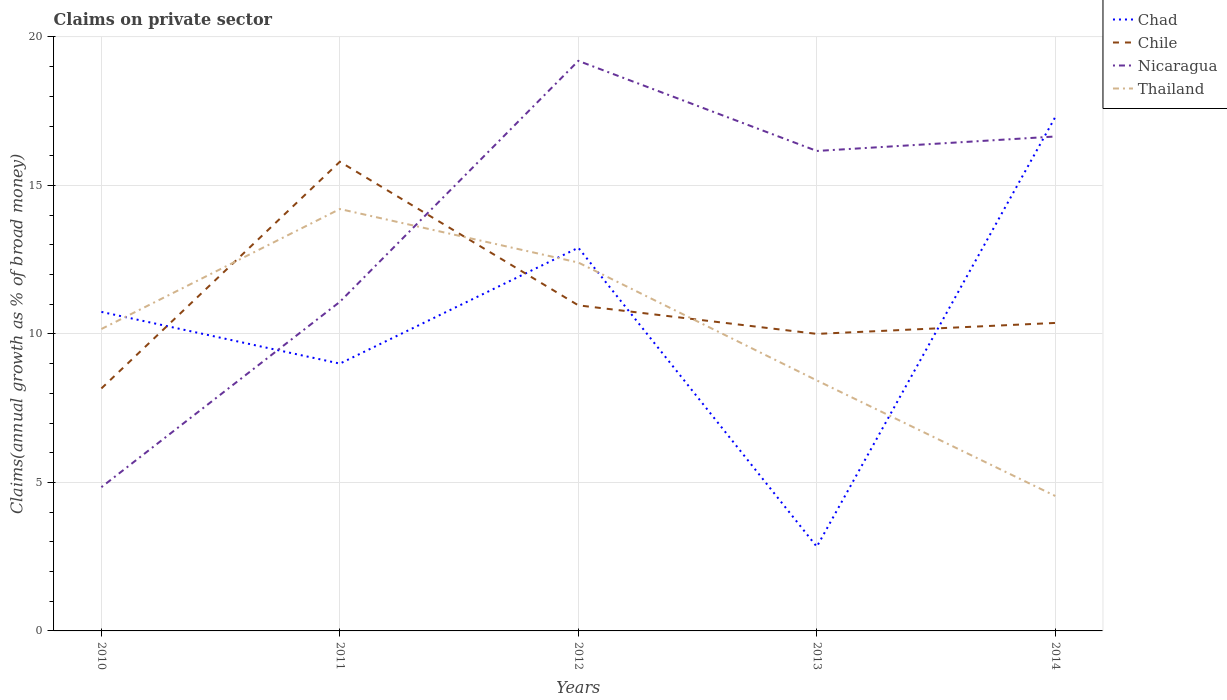How many different coloured lines are there?
Offer a terse response. 4. Across all years, what is the maximum percentage of broad money claimed on private sector in Thailand?
Provide a short and direct response. 4.54. In which year was the percentage of broad money claimed on private sector in Chad maximum?
Provide a short and direct response. 2013. What is the total percentage of broad money claimed on private sector in Nicaragua in the graph?
Your response must be concise. 2.55. What is the difference between the highest and the second highest percentage of broad money claimed on private sector in Chile?
Offer a terse response. 7.63. What is the difference between the highest and the lowest percentage of broad money claimed on private sector in Chad?
Give a very brief answer. 3. Is the percentage of broad money claimed on private sector in Chad strictly greater than the percentage of broad money claimed on private sector in Chile over the years?
Your response must be concise. No. How many lines are there?
Offer a very short reply. 4. Does the graph contain any zero values?
Ensure brevity in your answer.  No. Where does the legend appear in the graph?
Ensure brevity in your answer.  Top right. How many legend labels are there?
Provide a succinct answer. 4. How are the legend labels stacked?
Keep it short and to the point. Vertical. What is the title of the graph?
Give a very brief answer. Claims on private sector. Does "Guatemala" appear as one of the legend labels in the graph?
Keep it short and to the point. No. What is the label or title of the Y-axis?
Ensure brevity in your answer.  Claims(annual growth as % of broad money). What is the Claims(annual growth as % of broad money) of Chad in 2010?
Offer a terse response. 10.74. What is the Claims(annual growth as % of broad money) in Chile in 2010?
Your answer should be compact. 8.16. What is the Claims(annual growth as % of broad money) of Nicaragua in 2010?
Your response must be concise. 4.84. What is the Claims(annual growth as % of broad money) of Thailand in 2010?
Make the answer very short. 10.17. What is the Claims(annual growth as % of broad money) of Chad in 2011?
Your answer should be very brief. 9. What is the Claims(annual growth as % of broad money) of Chile in 2011?
Keep it short and to the point. 15.8. What is the Claims(annual growth as % of broad money) of Nicaragua in 2011?
Make the answer very short. 11.08. What is the Claims(annual growth as % of broad money) of Thailand in 2011?
Make the answer very short. 14.21. What is the Claims(annual growth as % of broad money) of Chad in 2012?
Provide a succinct answer. 12.9. What is the Claims(annual growth as % of broad money) in Chile in 2012?
Provide a succinct answer. 10.96. What is the Claims(annual growth as % of broad money) in Nicaragua in 2012?
Your answer should be very brief. 19.2. What is the Claims(annual growth as % of broad money) of Thailand in 2012?
Make the answer very short. 12.4. What is the Claims(annual growth as % of broad money) in Chad in 2013?
Give a very brief answer. 2.84. What is the Claims(annual growth as % of broad money) in Chile in 2013?
Ensure brevity in your answer.  10. What is the Claims(annual growth as % of broad money) of Nicaragua in 2013?
Your answer should be very brief. 16.16. What is the Claims(annual growth as % of broad money) in Thailand in 2013?
Offer a very short reply. 8.44. What is the Claims(annual growth as % of broad money) of Chad in 2014?
Provide a short and direct response. 17.3. What is the Claims(annual growth as % of broad money) in Chile in 2014?
Provide a succinct answer. 10.37. What is the Claims(annual growth as % of broad money) of Nicaragua in 2014?
Ensure brevity in your answer.  16.65. What is the Claims(annual growth as % of broad money) in Thailand in 2014?
Provide a short and direct response. 4.54. Across all years, what is the maximum Claims(annual growth as % of broad money) in Chad?
Your answer should be very brief. 17.3. Across all years, what is the maximum Claims(annual growth as % of broad money) in Chile?
Keep it short and to the point. 15.8. Across all years, what is the maximum Claims(annual growth as % of broad money) of Nicaragua?
Ensure brevity in your answer.  19.2. Across all years, what is the maximum Claims(annual growth as % of broad money) in Thailand?
Your answer should be compact. 14.21. Across all years, what is the minimum Claims(annual growth as % of broad money) of Chad?
Give a very brief answer. 2.84. Across all years, what is the minimum Claims(annual growth as % of broad money) in Chile?
Offer a terse response. 8.16. Across all years, what is the minimum Claims(annual growth as % of broad money) of Nicaragua?
Offer a very short reply. 4.84. Across all years, what is the minimum Claims(annual growth as % of broad money) in Thailand?
Give a very brief answer. 4.54. What is the total Claims(annual growth as % of broad money) in Chad in the graph?
Give a very brief answer. 52.79. What is the total Claims(annual growth as % of broad money) of Chile in the graph?
Your answer should be very brief. 55.3. What is the total Claims(annual growth as % of broad money) in Nicaragua in the graph?
Offer a terse response. 67.93. What is the total Claims(annual growth as % of broad money) in Thailand in the graph?
Offer a terse response. 49.76. What is the difference between the Claims(annual growth as % of broad money) of Chad in 2010 and that in 2011?
Your response must be concise. 1.74. What is the difference between the Claims(annual growth as % of broad money) in Chile in 2010 and that in 2011?
Provide a short and direct response. -7.63. What is the difference between the Claims(annual growth as % of broad money) in Nicaragua in 2010 and that in 2011?
Make the answer very short. -6.24. What is the difference between the Claims(annual growth as % of broad money) of Thailand in 2010 and that in 2011?
Keep it short and to the point. -4.04. What is the difference between the Claims(annual growth as % of broad money) in Chad in 2010 and that in 2012?
Provide a succinct answer. -2.16. What is the difference between the Claims(annual growth as % of broad money) in Chile in 2010 and that in 2012?
Give a very brief answer. -2.8. What is the difference between the Claims(annual growth as % of broad money) of Nicaragua in 2010 and that in 2012?
Make the answer very short. -14.35. What is the difference between the Claims(annual growth as % of broad money) of Thailand in 2010 and that in 2012?
Provide a short and direct response. -2.24. What is the difference between the Claims(annual growth as % of broad money) in Chad in 2010 and that in 2013?
Your response must be concise. 7.91. What is the difference between the Claims(annual growth as % of broad money) of Chile in 2010 and that in 2013?
Provide a short and direct response. -1.84. What is the difference between the Claims(annual growth as % of broad money) in Nicaragua in 2010 and that in 2013?
Provide a succinct answer. -11.32. What is the difference between the Claims(annual growth as % of broad money) of Thailand in 2010 and that in 2013?
Your response must be concise. 1.73. What is the difference between the Claims(annual growth as % of broad money) in Chad in 2010 and that in 2014?
Offer a very short reply. -6.56. What is the difference between the Claims(annual growth as % of broad money) in Chile in 2010 and that in 2014?
Give a very brief answer. -2.21. What is the difference between the Claims(annual growth as % of broad money) in Nicaragua in 2010 and that in 2014?
Offer a terse response. -11.81. What is the difference between the Claims(annual growth as % of broad money) of Thailand in 2010 and that in 2014?
Give a very brief answer. 5.62. What is the difference between the Claims(annual growth as % of broad money) in Chad in 2011 and that in 2012?
Make the answer very short. -3.9. What is the difference between the Claims(annual growth as % of broad money) in Chile in 2011 and that in 2012?
Provide a short and direct response. 4.84. What is the difference between the Claims(annual growth as % of broad money) of Nicaragua in 2011 and that in 2012?
Provide a succinct answer. -8.11. What is the difference between the Claims(annual growth as % of broad money) in Thailand in 2011 and that in 2012?
Offer a very short reply. 1.8. What is the difference between the Claims(annual growth as % of broad money) of Chad in 2011 and that in 2013?
Provide a short and direct response. 6.17. What is the difference between the Claims(annual growth as % of broad money) in Chile in 2011 and that in 2013?
Keep it short and to the point. 5.8. What is the difference between the Claims(annual growth as % of broad money) of Nicaragua in 2011 and that in 2013?
Your answer should be very brief. -5.08. What is the difference between the Claims(annual growth as % of broad money) in Thailand in 2011 and that in 2013?
Keep it short and to the point. 5.77. What is the difference between the Claims(annual growth as % of broad money) in Chad in 2011 and that in 2014?
Offer a very short reply. -8.3. What is the difference between the Claims(annual growth as % of broad money) of Chile in 2011 and that in 2014?
Your answer should be compact. 5.43. What is the difference between the Claims(annual growth as % of broad money) of Nicaragua in 2011 and that in 2014?
Offer a terse response. -5.57. What is the difference between the Claims(annual growth as % of broad money) of Thailand in 2011 and that in 2014?
Your answer should be very brief. 9.66. What is the difference between the Claims(annual growth as % of broad money) of Chad in 2012 and that in 2013?
Provide a succinct answer. 10.07. What is the difference between the Claims(annual growth as % of broad money) in Chile in 2012 and that in 2013?
Ensure brevity in your answer.  0.96. What is the difference between the Claims(annual growth as % of broad money) of Nicaragua in 2012 and that in 2013?
Offer a terse response. 3.03. What is the difference between the Claims(annual growth as % of broad money) in Thailand in 2012 and that in 2013?
Provide a succinct answer. 3.97. What is the difference between the Claims(annual growth as % of broad money) of Chad in 2012 and that in 2014?
Offer a very short reply. -4.4. What is the difference between the Claims(annual growth as % of broad money) in Chile in 2012 and that in 2014?
Your response must be concise. 0.59. What is the difference between the Claims(annual growth as % of broad money) in Nicaragua in 2012 and that in 2014?
Provide a short and direct response. 2.55. What is the difference between the Claims(annual growth as % of broad money) in Thailand in 2012 and that in 2014?
Your response must be concise. 7.86. What is the difference between the Claims(annual growth as % of broad money) of Chad in 2013 and that in 2014?
Provide a short and direct response. -14.47. What is the difference between the Claims(annual growth as % of broad money) in Chile in 2013 and that in 2014?
Give a very brief answer. -0.37. What is the difference between the Claims(annual growth as % of broad money) in Nicaragua in 2013 and that in 2014?
Your answer should be very brief. -0.49. What is the difference between the Claims(annual growth as % of broad money) in Thailand in 2013 and that in 2014?
Your answer should be compact. 3.89. What is the difference between the Claims(annual growth as % of broad money) in Chad in 2010 and the Claims(annual growth as % of broad money) in Chile in 2011?
Make the answer very short. -5.06. What is the difference between the Claims(annual growth as % of broad money) of Chad in 2010 and the Claims(annual growth as % of broad money) of Nicaragua in 2011?
Provide a short and direct response. -0.34. What is the difference between the Claims(annual growth as % of broad money) of Chad in 2010 and the Claims(annual growth as % of broad money) of Thailand in 2011?
Make the answer very short. -3.46. What is the difference between the Claims(annual growth as % of broad money) of Chile in 2010 and the Claims(annual growth as % of broad money) of Nicaragua in 2011?
Your response must be concise. -2.92. What is the difference between the Claims(annual growth as % of broad money) in Chile in 2010 and the Claims(annual growth as % of broad money) in Thailand in 2011?
Keep it short and to the point. -6.04. What is the difference between the Claims(annual growth as % of broad money) in Nicaragua in 2010 and the Claims(annual growth as % of broad money) in Thailand in 2011?
Keep it short and to the point. -9.37. What is the difference between the Claims(annual growth as % of broad money) in Chad in 2010 and the Claims(annual growth as % of broad money) in Chile in 2012?
Your response must be concise. -0.22. What is the difference between the Claims(annual growth as % of broad money) in Chad in 2010 and the Claims(annual growth as % of broad money) in Nicaragua in 2012?
Offer a very short reply. -8.45. What is the difference between the Claims(annual growth as % of broad money) in Chad in 2010 and the Claims(annual growth as % of broad money) in Thailand in 2012?
Provide a short and direct response. -1.66. What is the difference between the Claims(annual growth as % of broad money) of Chile in 2010 and the Claims(annual growth as % of broad money) of Nicaragua in 2012?
Offer a terse response. -11.03. What is the difference between the Claims(annual growth as % of broad money) of Chile in 2010 and the Claims(annual growth as % of broad money) of Thailand in 2012?
Your response must be concise. -4.24. What is the difference between the Claims(annual growth as % of broad money) of Nicaragua in 2010 and the Claims(annual growth as % of broad money) of Thailand in 2012?
Ensure brevity in your answer.  -7.56. What is the difference between the Claims(annual growth as % of broad money) of Chad in 2010 and the Claims(annual growth as % of broad money) of Chile in 2013?
Give a very brief answer. 0.74. What is the difference between the Claims(annual growth as % of broad money) in Chad in 2010 and the Claims(annual growth as % of broad money) in Nicaragua in 2013?
Offer a terse response. -5.42. What is the difference between the Claims(annual growth as % of broad money) of Chad in 2010 and the Claims(annual growth as % of broad money) of Thailand in 2013?
Your answer should be compact. 2.31. What is the difference between the Claims(annual growth as % of broad money) of Chile in 2010 and the Claims(annual growth as % of broad money) of Nicaragua in 2013?
Your answer should be compact. -8. What is the difference between the Claims(annual growth as % of broad money) in Chile in 2010 and the Claims(annual growth as % of broad money) in Thailand in 2013?
Offer a very short reply. -0.27. What is the difference between the Claims(annual growth as % of broad money) in Nicaragua in 2010 and the Claims(annual growth as % of broad money) in Thailand in 2013?
Offer a terse response. -3.59. What is the difference between the Claims(annual growth as % of broad money) of Chad in 2010 and the Claims(annual growth as % of broad money) of Chile in 2014?
Your answer should be very brief. 0.37. What is the difference between the Claims(annual growth as % of broad money) in Chad in 2010 and the Claims(annual growth as % of broad money) in Nicaragua in 2014?
Offer a very short reply. -5.91. What is the difference between the Claims(annual growth as % of broad money) of Chad in 2010 and the Claims(annual growth as % of broad money) of Thailand in 2014?
Your answer should be compact. 6.2. What is the difference between the Claims(annual growth as % of broad money) of Chile in 2010 and the Claims(annual growth as % of broad money) of Nicaragua in 2014?
Your answer should be compact. -8.48. What is the difference between the Claims(annual growth as % of broad money) of Chile in 2010 and the Claims(annual growth as % of broad money) of Thailand in 2014?
Offer a terse response. 3.62. What is the difference between the Claims(annual growth as % of broad money) of Nicaragua in 2010 and the Claims(annual growth as % of broad money) of Thailand in 2014?
Your response must be concise. 0.3. What is the difference between the Claims(annual growth as % of broad money) in Chad in 2011 and the Claims(annual growth as % of broad money) in Chile in 2012?
Give a very brief answer. -1.96. What is the difference between the Claims(annual growth as % of broad money) of Chad in 2011 and the Claims(annual growth as % of broad money) of Nicaragua in 2012?
Ensure brevity in your answer.  -10.19. What is the difference between the Claims(annual growth as % of broad money) in Chad in 2011 and the Claims(annual growth as % of broad money) in Thailand in 2012?
Make the answer very short. -3.4. What is the difference between the Claims(annual growth as % of broad money) of Chile in 2011 and the Claims(annual growth as % of broad money) of Nicaragua in 2012?
Give a very brief answer. -3.4. What is the difference between the Claims(annual growth as % of broad money) of Chile in 2011 and the Claims(annual growth as % of broad money) of Thailand in 2012?
Give a very brief answer. 3.4. What is the difference between the Claims(annual growth as % of broad money) of Nicaragua in 2011 and the Claims(annual growth as % of broad money) of Thailand in 2012?
Your answer should be very brief. -1.32. What is the difference between the Claims(annual growth as % of broad money) in Chad in 2011 and the Claims(annual growth as % of broad money) in Chile in 2013?
Offer a terse response. -1. What is the difference between the Claims(annual growth as % of broad money) in Chad in 2011 and the Claims(annual growth as % of broad money) in Nicaragua in 2013?
Offer a very short reply. -7.16. What is the difference between the Claims(annual growth as % of broad money) in Chad in 2011 and the Claims(annual growth as % of broad money) in Thailand in 2013?
Offer a terse response. 0.57. What is the difference between the Claims(annual growth as % of broad money) of Chile in 2011 and the Claims(annual growth as % of broad money) of Nicaragua in 2013?
Your answer should be compact. -0.36. What is the difference between the Claims(annual growth as % of broad money) in Chile in 2011 and the Claims(annual growth as % of broad money) in Thailand in 2013?
Ensure brevity in your answer.  7.36. What is the difference between the Claims(annual growth as % of broad money) in Nicaragua in 2011 and the Claims(annual growth as % of broad money) in Thailand in 2013?
Offer a very short reply. 2.65. What is the difference between the Claims(annual growth as % of broad money) of Chad in 2011 and the Claims(annual growth as % of broad money) of Chile in 2014?
Keep it short and to the point. -1.37. What is the difference between the Claims(annual growth as % of broad money) of Chad in 2011 and the Claims(annual growth as % of broad money) of Nicaragua in 2014?
Offer a very short reply. -7.65. What is the difference between the Claims(annual growth as % of broad money) of Chad in 2011 and the Claims(annual growth as % of broad money) of Thailand in 2014?
Ensure brevity in your answer.  4.46. What is the difference between the Claims(annual growth as % of broad money) of Chile in 2011 and the Claims(annual growth as % of broad money) of Nicaragua in 2014?
Your answer should be very brief. -0.85. What is the difference between the Claims(annual growth as % of broad money) in Chile in 2011 and the Claims(annual growth as % of broad money) in Thailand in 2014?
Your answer should be compact. 11.26. What is the difference between the Claims(annual growth as % of broad money) in Nicaragua in 2011 and the Claims(annual growth as % of broad money) in Thailand in 2014?
Provide a short and direct response. 6.54. What is the difference between the Claims(annual growth as % of broad money) of Chad in 2012 and the Claims(annual growth as % of broad money) of Chile in 2013?
Give a very brief answer. 2.9. What is the difference between the Claims(annual growth as % of broad money) of Chad in 2012 and the Claims(annual growth as % of broad money) of Nicaragua in 2013?
Offer a very short reply. -3.26. What is the difference between the Claims(annual growth as % of broad money) of Chad in 2012 and the Claims(annual growth as % of broad money) of Thailand in 2013?
Provide a short and direct response. 4.47. What is the difference between the Claims(annual growth as % of broad money) in Chile in 2012 and the Claims(annual growth as % of broad money) in Nicaragua in 2013?
Provide a succinct answer. -5.2. What is the difference between the Claims(annual growth as % of broad money) in Chile in 2012 and the Claims(annual growth as % of broad money) in Thailand in 2013?
Offer a terse response. 2.53. What is the difference between the Claims(annual growth as % of broad money) of Nicaragua in 2012 and the Claims(annual growth as % of broad money) of Thailand in 2013?
Your answer should be very brief. 10.76. What is the difference between the Claims(annual growth as % of broad money) of Chad in 2012 and the Claims(annual growth as % of broad money) of Chile in 2014?
Ensure brevity in your answer.  2.53. What is the difference between the Claims(annual growth as % of broad money) of Chad in 2012 and the Claims(annual growth as % of broad money) of Nicaragua in 2014?
Make the answer very short. -3.75. What is the difference between the Claims(annual growth as % of broad money) of Chad in 2012 and the Claims(annual growth as % of broad money) of Thailand in 2014?
Keep it short and to the point. 8.36. What is the difference between the Claims(annual growth as % of broad money) of Chile in 2012 and the Claims(annual growth as % of broad money) of Nicaragua in 2014?
Make the answer very short. -5.69. What is the difference between the Claims(annual growth as % of broad money) in Chile in 2012 and the Claims(annual growth as % of broad money) in Thailand in 2014?
Ensure brevity in your answer.  6.42. What is the difference between the Claims(annual growth as % of broad money) in Nicaragua in 2012 and the Claims(annual growth as % of broad money) in Thailand in 2014?
Offer a very short reply. 14.65. What is the difference between the Claims(annual growth as % of broad money) of Chad in 2013 and the Claims(annual growth as % of broad money) of Chile in 2014?
Your response must be concise. -7.53. What is the difference between the Claims(annual growth as % of broad money) in Chad in 2013 and the Claims(annual growth as % of broad money) in Nicaragua in 2014?
Provide a short and direct response. -13.81. What is the difference between the Claims(annual growth as % of broad money) of Chad in 2013 and the Claims(annual growth as % of broad money) of Thailand in 2014?
Ensure brevity in your answer.  -1.71. What is the difference between the Claims(annual growth as % of broad money) in Chile in 2013 and the Claims(annual growth as % of broad money) in Nicaragua in 2014?
Offer a terse response. -6.65. What is the difference between the Claims(annual growth as % of broad money) in Chile in 2013 and the Claims(annual growth as % of broad money) in Thailand in 2014?
Provide a succinct answer. 5.46. What is the difference between the Claims(annual growth as % of broad money) of Nicaragua in 2013 and the Claims(annual growth as % of broad money) of Thailand in 2014?
Provide a succinct answer. 11.62. What is the average Claims(annual growth as % of broad money) in Chad per year?
Offer a very short reply. 10.56. What is the average Claims(annual growth as % of broad money) in Chile per year?
Provide a short and direct response. 11.06. What is the average Claims(annual growth as % of broad money) of Nicaragua per year?
Provide a short and direct response. 13.59. What is the average Claims(annual growth as % of broad money) in Thailand per year?
Give a very brief answer. 9.95. In the year 2010, what is the difference between the Claims(annual growth as % of broad money) of Chad and Claims(annual growth as % of broad money) of Chile?
Provide a succinct answer. 2.58. In the year 2010, what is the difference between the Claims(annual growth as % of broad money) in Chad and Claims(annual growth as % of broad money) in Nicaragua?
Provide a short and direct response. 5.9. In the year 2010, what is the difference between the Claims(annual growth as % of broad money) in Chad and Claims(annual growth as % of broad money) in Thailand?
Your answer should be very brief. 0.58. In the year 2010, what is the difference between the Claims(annual growth as % of broad money) of Chile and Claims(annual growth as % of broad money) of Nicaragua?
Provide a short and direct response. 3.32. In the year 2010, what is the difference between the Claims(annual growth as % of broad money) in Chile and Claims(annual growth as % of broad money) in Thailand?
Give a very brief answer. -2. In the year 2010, what is the difference between the Claims(annual growth as % of broad money) of Nicaragua and Claims(annual growth as % of broad money) of Thailand?
Your answer should be compact. -5.33. In the year 2011, what is the difference between the Claims(annual growth as % of broad money) in Chad and Claims(annual growth as % of broad money) in Chile?
Make the answer very short. -6.8. In the year 2011, what is the difference between the Claims(annual growth as % of broad money) of Chad and Claims(annual growth as % of broad money) of Nicaragua?
Make the answer very short. -2.08. In the year 2011, what is the difference between the Claims(annual growth as % of broad money) of Chad and Claims(annual growth as % of broad money) of Thailand?
Make the answer very short. -5.21. In the year 2011, what is the difference between the Claims(annual growth as % of broad money) in Chile and Claims(annual growth as % of broad money) in Nicaragua?
Your answer should be compact. 4.72. In the year 2011, what is the difference between the Claims(annual growth as % of broad money) in Chile and Claims(annual growth as % of broad money) in Thailand?
Offer a terse response. 1.59. In the year 2011, what is the difference between the Claims(annual growth as % of broad money) of Nicaragua and Claims(annual growth as % of broad money) of Thailand?
Your response must be concise. -3.12. In the year 2012, what is the difference between the Claims(annual growth as % of broad money) of Chad and Claims(annual growth as % of broad money) of Chile?
Your response must be concise. 1.94. In the year 2012, what is the difference between the Claims(annual growth as % of broad money) in Chad and Claims(annual growth as % of broad money) in Nicaragua?
Keep it short and to the point. -6.29. In the year 2012, what is the difference between the Claims(annual growth as % of broad money) in Chad and Claims(annual growth as % of broad money) in Thailand?
Offer a very short reply. 0.5. In the year 2012, what is the difference between the Claims(annual growth as % of broad money) of Chile and Claims(annual growth as % of broad money) of Nicaragua?
Give a very brief answer. -8.23. In the year 2012, what is the difference between the Claims(annual growth as % of broad money) of Chile and Claims(annual growth as % of broad money) of Thailand?
Give a very brief answer. -1.44. In the year 2012, what is the difference between the Claims(annual growth as % of broad money) in Nicaragua and Claims(annual growth as % of broad money) in Thailand?
Your response must be concise. 6.79. In the year 2013, what is the difference between the Claims(annual growth as % of broad money) in Chad and Claims(annual growth as % of broad money) in Chile?
Your answer should be very brief. -7.17. In the year 2013, what is the difference between the Claims(annual growth as % of broad money) of Chad and Claims(annual growth as % of broad money) of Nicaragua?
Ensure brevity in your answer.  -13.33. In the year 2013, what is the difference between the Claims(annual growth as % of broad money) in Chad and Claims(annual growth as % of broad money) in Thailand?
Your response must be concise. -5.6. In the year 2013, what is the difference between the Claims(annual growth as % of broad money) in Chile and Claims(annual growth as % of broad money) in Nicaragua?
Provide a short and direct response. -6.16. In the year 2013, what is the difference between the Claims(annual growth as % of broad money) of Chile and Claims(annual growth as % of broad money) of Thailand?
Offer a terse response. 1.57. In the year 2013, what is the difference between the Claims(annual growth as % of broad money) in Nicaragua and Claims(annual growth as % of broad money) in Thailand?
Provide a short and direct response. 7.73. In the year 2014, what is the difference between the Claims(annual growth as % of broad money) of Chad and Claims(annual growth as % of broad money) of Chile?
Offer a terse response. 6.93. In the year 2014, what is the difference between the Claims(annual growth as % of broad money) of Chad and Claims(annual growth as % of broad money) of Nicaragua?
Ensure brevity in your answer.  0.65. In the year 2014, what is the difference between the Claims(annual growth as % of broad money) of Chad and Claims(annual growth as % of broad money) of Thailand?
Your response must be concise. 12.76. In the year 2014, what is the difference between the Claims(annual growth as % of broad money) in Chile and Claims(annual growth as % of broad money) in Nicaragua?
Make the answer very short. -6.28. In the year 2014, what is the difference between the Claims(annual growth as % of broad money) of Chile and Claims(annual growth as % of broad money) of Thailand?
Offer a very short reply. 5.83. In the year 2014, what is the difference between the Claims(annual growth as % of broad money) in Nicaragua and Claims(annual growth as % of broad money) in Thailand?
Provide a succinct answer. 12.1. What is the ratio of the Claims(annual growth as % of broad money) of Chad in 2010 to that in 2011?
Your answer should be very brief. 1.19. What is the ratio of the Claims(annual growth as % of broad money) of Chile in 2010 to that in 2011?
Give a very brief answer. 0.52. What is the ratio of the Claims(annual growth as % of broad money) of Nicaragua in 2010 to that in 2011?
Make the answer very short. 0.44. What is the ratio of the Claims(annual growth as % of broad money) of Thailand in 2010 to that in 2011?
Give a very brief answer. 0.72. What is the ratio of the Claims(annual growth as % of broad money) of Chad in 2010 to that in 2012?
Give a very brief answer. 0.83. What is the ratio of the Claims(annual growth as % of broad money) in Chile in 2010 to that in 2012?
Give a very brief answer. 0.74. What is the ratio of the Claims(annual growth as % of broad money) of Nicaragua in 2010 to that in 2012?
Make the answer very short. 0.25. What is the ratio of the Claims(annual growth as % of broad money) of Thailand in 2010 to that in 2012?
Offer a terse response. 0.82. What is the ratio of the Claims(annual growth as % of broad money) of Chad in 2010 to that in 2013?
Give a very brief answer. 3.79. What is the ratio of the Claims(annual growth as % of broad money) of Chile in 2010 to that in 2013?
Your answer should be compact. 0.82. What is the ratio of the Claims(annual growth as % of broad money) in Nicaragua in 2010 to that in 2013?
Your answer should be compact. 0.3. What is the ratio of the Claims(annual growth as % of broad money) in Thailand in 2010 to that in 2013?
Your response must be concise. 1.21. What is the ratio of the Claims(annual growth as % of broad money) of Chad in 2010 to that in 2014?
Your answer should be very brief. 0.62. What is the ratio of the Claims(annual growth as % of broad money) in Chile in 2010 to that in 2014?
Your answer should be very brief. 0.79. What is the ratio of the Claims(annual growth as % of broad money) in Nicaragua in 2010 to that in 2014?
Offer a terse response. 0.29. What is the ratio of the Claims(annual growth as % of broad money) of Thailand in 2010 to that in 2014?
Ensure brevity in your answer.  2.24. What is the ratio of the Claims(annual growth as % of broad money) in Chad in 2011 to that in 2012?
Provide a succinct answer. 0.7. What is the ratio of the Claims(annual growth as % of broad money) of Chile in 2011 to that in 2012?
Give a very brief answer. 1.44. What is the ratio of the Claims(annual growth as % of broad money) of Nicaragua in 2011 to that in 2012?
Your answer should be very brief. 0.58. What is the ratio of the Claims(annual growth as % of broad money) in Thailand in 2011 to that in 2012?
Ensure brevity in your answer.  1.15. What is the ratio of the Claims(annual growth as % of broad money) of Chad in 2011 to that in 2013?
Provide a succinct answer. 3.17. What is the ratio of the Claims(annual growth as % of broad money) in Chile in 2011 to that in 2013?
Your answer should be compact. 1.58. What is the ratio of the Claims(annual growth as % of broad money) of Nicaragua in 2011 to that in 2013?
Provide a succinct answer. 0.69. What is the ratio of the Claims(annual growth as % of broad money) of Thailand in 2011 to that in 2013?
Keep it short and to the point. 1.68. What is the ratio of the Claims(annual growth as % of broad money) in Chad in 2011 to that in 2014?
Provide a succinct answer. 0.52. What is the ratio of the Claims(annual growth as % of broad money) in Chile in 2011 to that in 2014?
Offer a terse response. 1.52. What is the ratio of the Claims(annual growth as % of broad money) of Nicaragua in 2011 to that in 2014?
Your answer should be compact. 0.67. What is the ratio of the Claims(annual growth as % of broad money) of Thailand in 2011 to that in 2014?
Your answer should be very brief. 3.13. What is the ratio of the Claims(annual growth as % of broad money) in Chad in 2012 to that in 2013?
Give a very brief answer. 4.55. What is the ratio of the Claims(annual growth as % of broad money) in Chile in 2012 to that in 2013?
Your answer should be very brief. 1.1. What is the ratio of the Claims(annual growth as % of broad money) of Nicaragua in 2012 to that in 2013?
Offer a terse response. 1.19. What is the ratio of the Claims(annual growth as % of broad money) of Thailand in 2012 to that in 2013?
Your answer should be very brief. 1.47. What is the ratio of the Claims(annual growth as % of broad money) of Chad in 2012 to that in 2014?
Your answer should be very brief. 0.75. What is the ratio of the Claims(annual growth as % of broad money) in Chile in 2012 to that in 2014?
Provide a succinct answer. 1.06. What is the ratio of the Claims(annual growth as % of broad money) of Nicaragua in 2012 to that in 2014?
Keep it short and to the point. 1.15. What is the ratio of the Claims(annual growth as % of broad money) of Thailand in 2012 to that in 2014?
Keep it short and to the point. 2.73. What is the ratio of the Claims(annual growth as % of broad money) of Chad in 2013 to that in 2014?
Keep it short and to the point. 0.16. What is the ratio of the Claims(annual growth as % of broad money) in Chile in 2013 to that in 2014?
Make the answer very short. 0.96. What is the ratio of the Claims(annual growth as % of broad money) of Nicaragua in 2013 to that in 2014?
Ensure brevity in your answer.  0.97. What is the ratio of the Claims(annual growth as % of broad money) in Thailand in 2013 to that in 2014?
Give a very brief answer. 1.86. What is the difference between the highest and the second highest Claims(annual growth as % of broad money) in Chad?
Provide a short and direct response. 4.4. What is the difference between the highest and the second highest Claims(annual growth as % of broad money) in Chile?
Ensure brevity in your answer.  4.84. What is the difference between the highest and the second highest Claims(annual growth as % of broad money) in Nicaragua?
Provide a short and direct response. 2.55. What is the difference between the highest and the second highest Claims(annual growth as % of broad money) of Thailand?
Ensure brevity in your answer.  1.8. What is the difference between the highest and the lowest Claims(annual growth as % of broad money) of Chad?
Make the answer very short. 14.47. What is the difference between the highest and the lowest Claims(annual growth as % of broad money) of Chile?
Provide a short and direct response. 7.63. What is the difference between the highest and the lowest Claims(annual growth as % of broad money) of Nicaragua?
Provide a succinct answer. 14.35. What is the difference between the highest and the lowest Claims(annual growth as % of broad money) in Thailand?
Offer a very short reply. 9.66. 